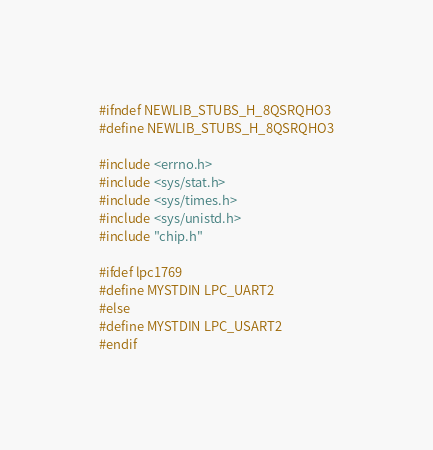Convert code to text. <code><loc_0><loc_0><loc_500><loc_500><_C_>#ifndef NEWLIB_STUBS_H_8QSRQHO3
#define NEWLIB_STUBS_H_8QSRQHO3

#include <errno.h>
#include <sys/stat.h>
#include <sys/times.h>
#include <sys/unistd.h>
#include "chip.h"

#ifdef lpc1769
#define MYSTDIN LPC_UART2
#else
#define MYSTDIN LPC_USART2
#endif
</code> 